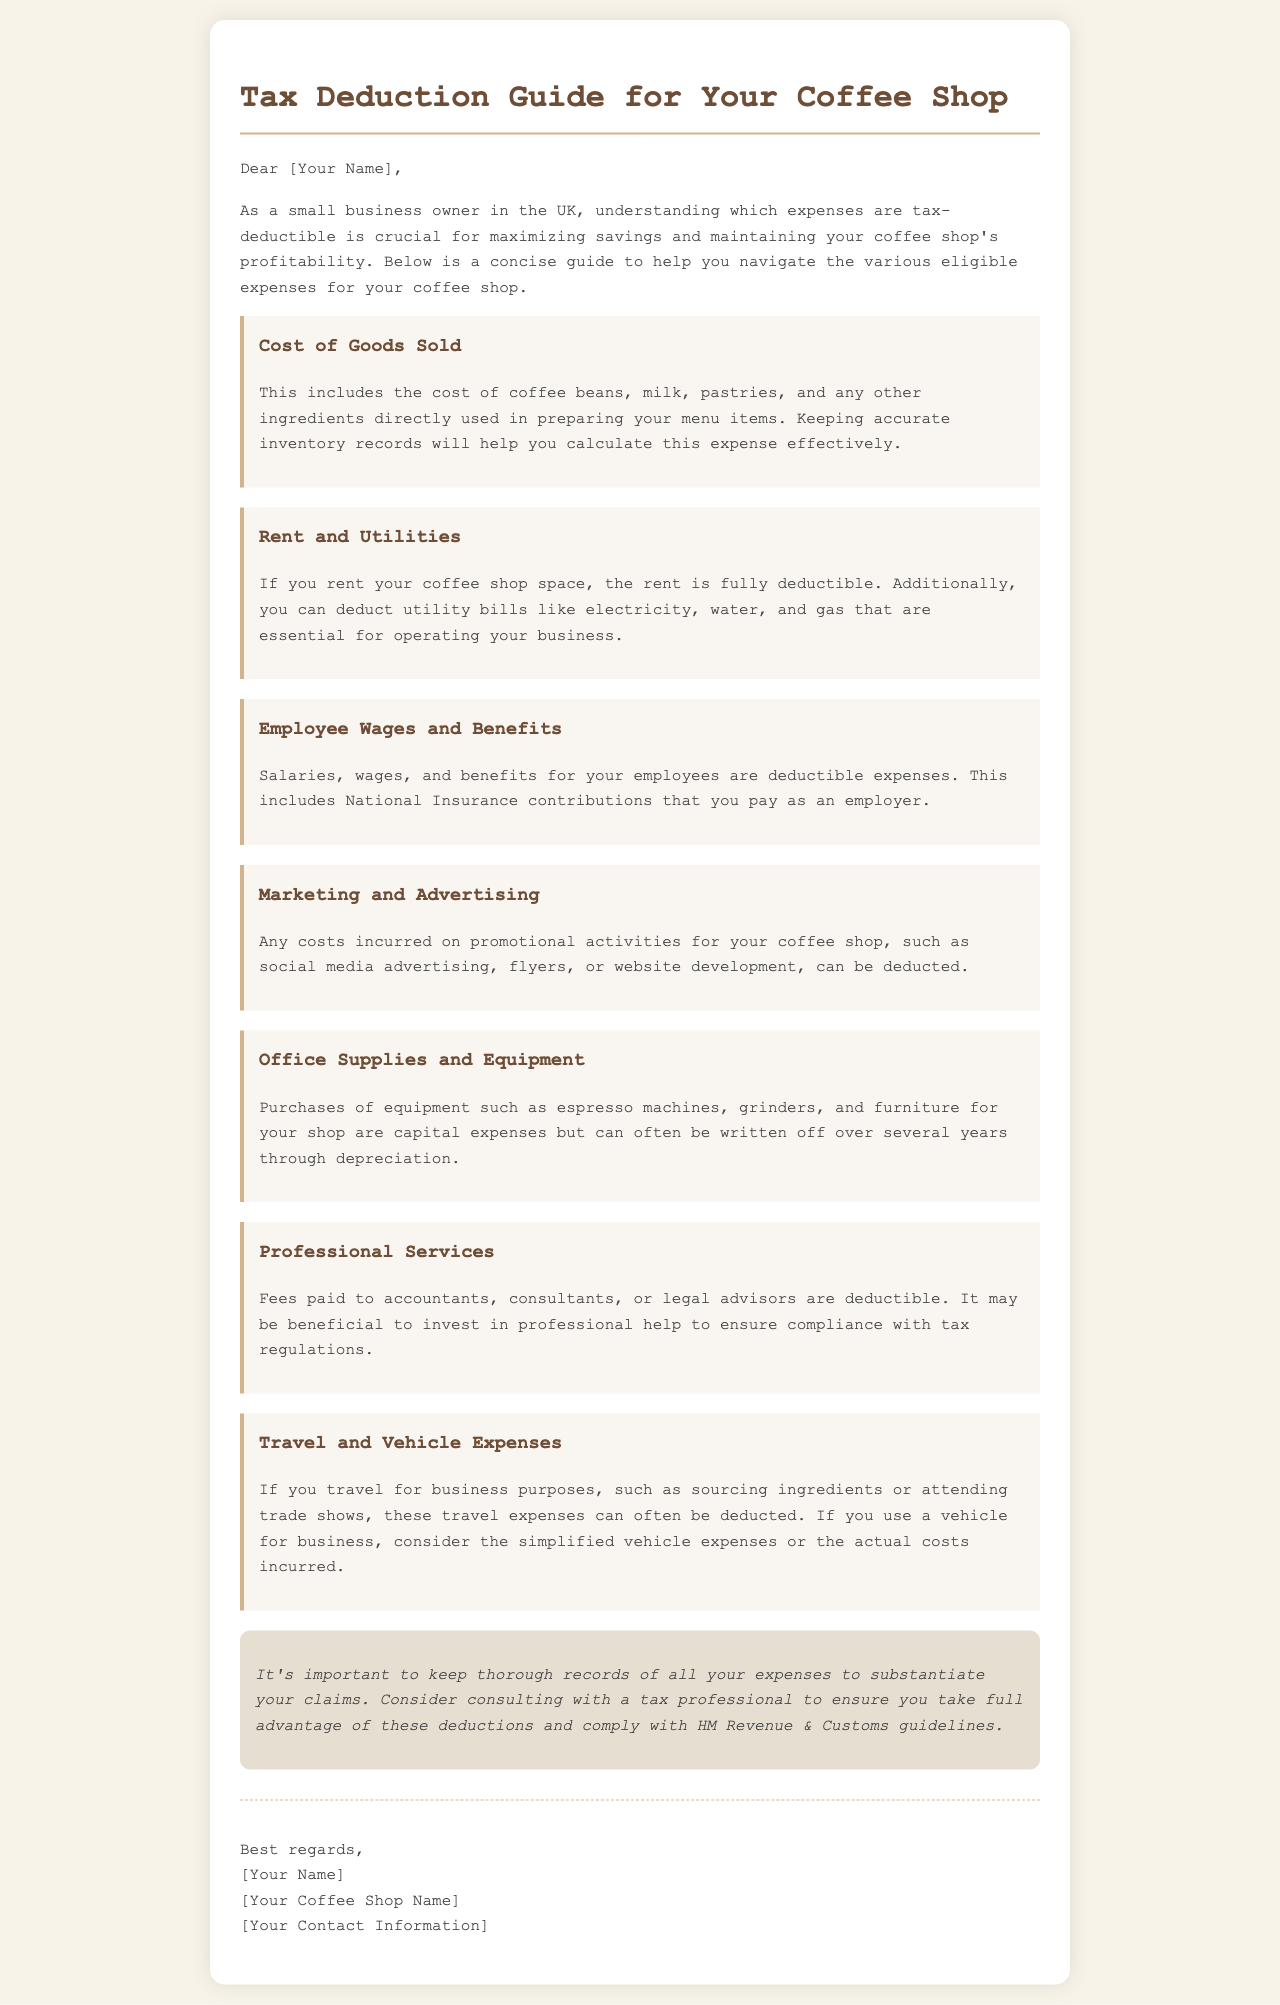What are the eligible expenses for tax deductions? The document outlines several eligible expenses for tax deductions tailored for small business owners, like coffee shop owners.
Answer: Cost of Goods Sold, Rent and Utilities, Employee Wages and Benefits, Marketing and Advertising, Office Supplies and Equipment, Professional Services, Travel and Vehicle Expenses What can be deducted under the Cost of Goods Sold? The section on Cost of Goods Sold specifies that it includes the cost of ingredients directly used in preparing menu items.
Answer: Coffee beans, milk, pastries, and other ingredients How is rent treated for tax purposes? The document states that if you rent your coffee shop space, the rent is fully deductible.
Answer: Fully deductible What type of expenses can be deducted for marketing? The marketing section specifies that costs incurred for promotional activities can be deducted.
Answer: Promotional activities What type of professional services are deductible? The document specifies fees paid to certain service providers as deductible.
Answer: Accountants, consultants, or legal advisors What are the tax benefits of employee wages? The document mentions that employee wages and benefits can be deducted expenses for tax purposes.
Answer: Deductible expenses In what way can office supplies and equipment be handled for deductions? The office supplies section notes that equipment purchases are capital expenses but can be written off over time.
Answer: Written off over several years through depreciation What should you consider when keeping records of your expenses? The document emphasizes the importance of keeping thorough records to substantiate tax claims.
Answer: Keep thorough records Who should you consult for maximizing tax deductions? The conclusion section suggests that seeking professional advice is beneficial.
Answer: Tax professional 